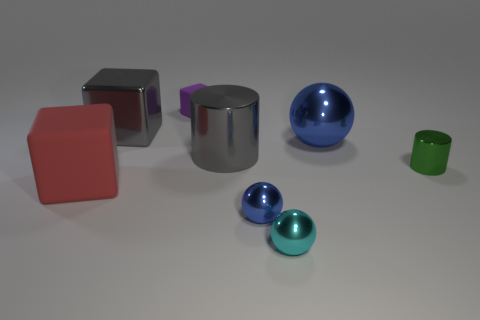There is a blue shiny thing to the left of the cyan ball; does it have the same shape as the tiny metallic thing that is on the right side of the cyan object?
Your response must be concise. No. The tiny object that is in front of the green cylinder and behind the cyan metallic ball is made of what material?
Your answer should be very brief. Metal. The tiny cylinder that is the same material as the tiny blue sphere is what color?
Ensure brevity in your answer.  Green. There is a big object that is the same color as the big metal block; what is it made of?
Your answer should be very brief. Metal. The big thing that is in front of the big blue ball and on the right side of the gray metal block has what shape?
Your answer should be compact. Cylinder. Are there fewer red rubber things that are on the right side of the small matte block than cylinders?
Provide a succinct answer. Yes. There is a matte object that is behind the red rubber block; are there any red matte objects behind it?
Your answer should be compact. No. Is there anything else that is the same shape as the tiny green metallic object?
Ensure brevity in your answer.  Yes. Is the size of the cyan metal object the same as the green shiny cylinder?
Offer a very short reply. Yes. What is the blue object that is in front of the matte cube that is in front of the shiny cylinder on the right side of the cyan shiny object made of?
Provide a succinct answer. Metal. 